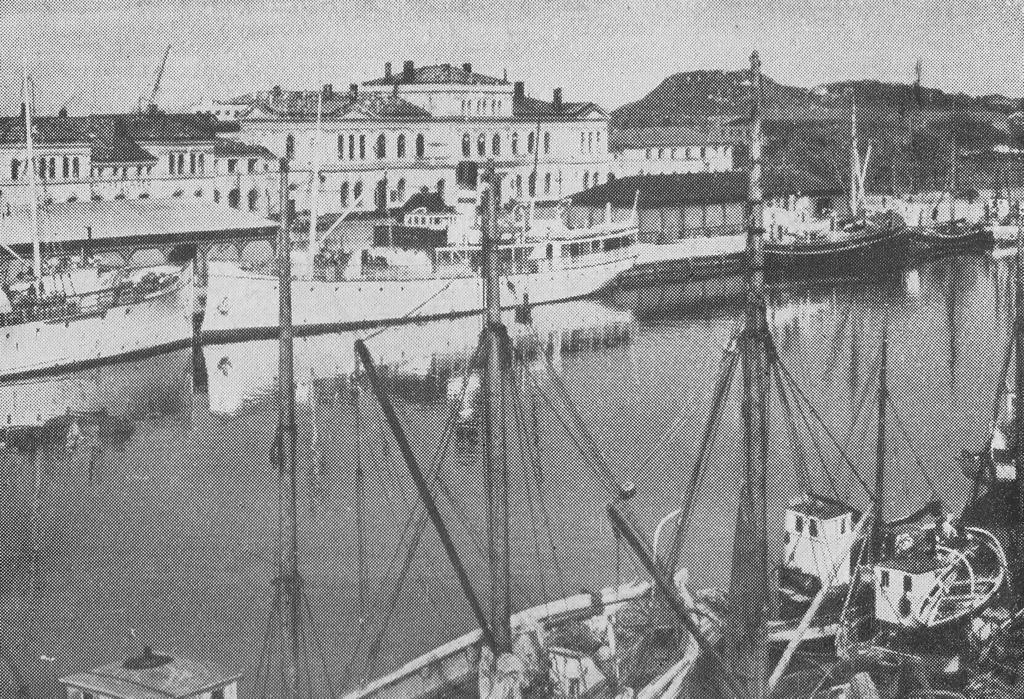What type of vehicles can be seen in the image? There are boats in the image. What natural element is visible in the image? There is water visible in the image. What type of man-made structures are present in the image? There are buildings in the image. What type of geographical feature can be seen in the image? There are hills in the image. What is visible at the top of the image? The sky is visible at the top of the image. Where are the children playing in the image? There are no children present in the image. What type of scene is depicted in the image? The image does not depict a specific scene; it features boats, water, buildings, hills, and the sky. Is there any quicksand visible in the image? There is no quicksand present in the image. 